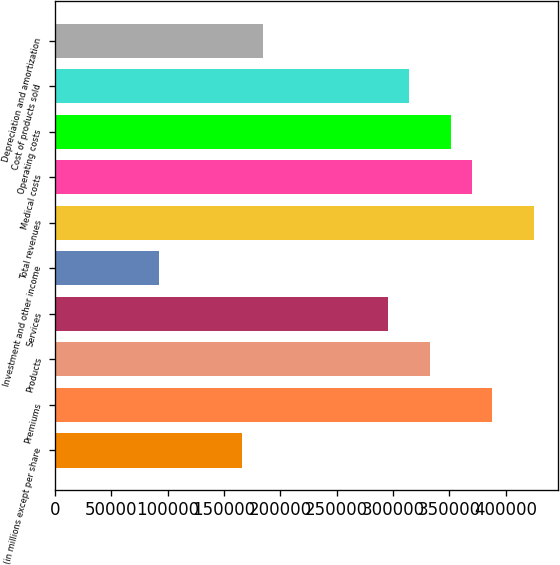Convert chart to OTSL. <chart><loc_0><loc_0><loc_500><loc_500><bar_chart><fcel>(in millions except per share<fcel>Premiums<fcel>Products<fcel>Services<fcel>Investment and other income<fcel>Total revenues<fcel>Medical costs<fcel>Operating costs<fcel>Cost of products sold<fcel>Depreciation and amortization<nl><fcel>166356<fcel>388161<fcel>332710<fcel>295743<fcel>92421.2<fcel>425129<fcel>369678<fcel>351194<fcel>314226<fcel>184840<nl></chart> 